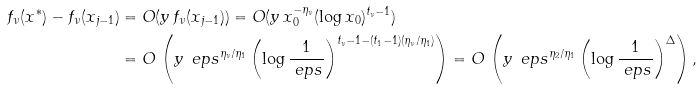Convert formula to latex. <formula><loc_0><loc_0><loc_500><loc_500>f _ { \nu } ( x ^ { * } ) - f _ { \nu } ( x _ { j - 1 } ) & = O ( y \, f _ { \nu } ( x _ { j - 1 } ) ) = O ( y \, x _ { 0 } ^ { - \eta _ { \nu } } ( \log x _ { 0 } ) ^ { t _ { \nu } - 1 } ) \\ & = O \, \left ( y \, \ e p s ^ { \eta _ { \nu } / \eta _ { 1 } } \left ( \log \frac { 1 } { \ e p s } \right ) ^ { t _ { \nu } - 1 - ( t _ { 1 } - 1 ) ( \eta _ { \nu } / \eta _ { 1 } ) } \right ) = O \, \left ( y \, \ e p s ^ { \eta _ { 2 } / \eta _ { 1 } } \left ( \log \frac { 1 } { \ e p s } \right ) ^ { \Delta } \right ) ,</formula> 